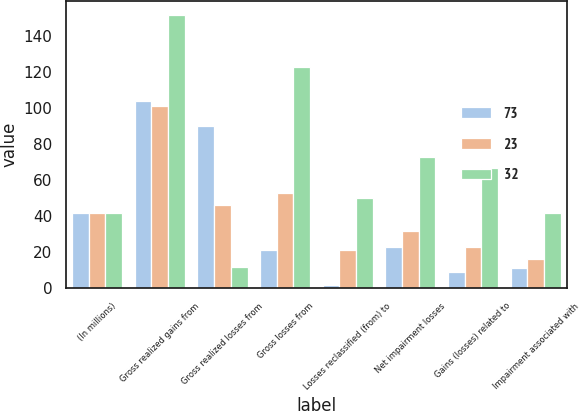<chart> <loc_0><loc_0><loc_500><loc_500><stacked_bar_chart><ecel><fcel>(In millions)<fcel>Gross realized gains from<fcel>Gross realized losses from<fcel>Gross losses from<fcel>Losses reclassified (from) to<fcel>Net impairment losses<fcel>Gains (losses) related to<fcel>Impairment associated with<nl><fcel>73<fcel>42<fcel>104<fcel>90<fcel>21<fcel>2<fcel>23<fcel>9<fcel>11<nl><fcel>23<fcel>42<fcel>101<fcel>46<fcel>53<fcel>21<fcel>32<fcel>23<fcel>16<nl><fcel>32<fcel>42<fcel>152<fcel>12<fcel>123<fcel>50<fcel>73<fcel>67<fcel>42<nl></chart> 